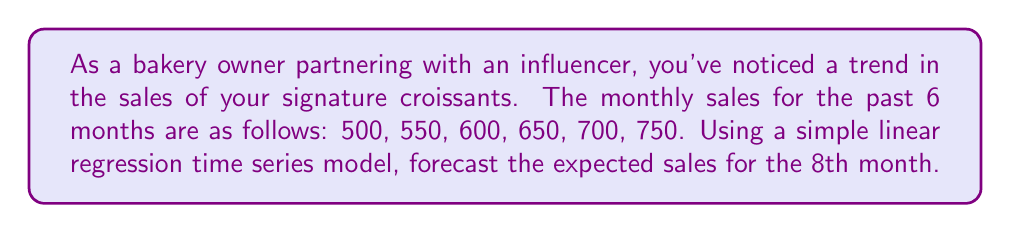Give your solution to this math problem. To forecast the sales for the 8th month using a simple linear regression time series model, we'll follow these steps:

1) First, let's set up our data:
   Time (t): 1, 2, 3, 4, 5, 6
   Sales (Y): 500, 550, 600, 650, 700, 750

2) We need to find the equation of the line: $Y = a + bt$, where:
   $a$ is the y-intercept
   $b$ is the slope
   $t$ is the time period

3) To find $b$, we use the formula:
   $$b = \frac{n\sum{ty} - \sum{t}\sum{y}}{n\sum{t^2} - (\sum{t})^2}$$

   Where $n$ is the number of data points (6 in this case)

4) Let's calculate the necessary sums:
   $\sum{t} = 1 + 2 + 3 + 4 + 5 + 6 = 21$
   $\sum{y} = 500 + 550 + 600 + 650 + 700 + 750 = 3750$
   $\sum{ty} = 1(500) + 2(550) + 3(600) + 4(650) + 5(700) + 6(750) = 13,900$
   $\sum{t^2} = 1^2 + 2^2 + 3^2 + 4^2 + 5^2 + 6^2 = 91$

5) Now we can calculate $b$:
   $$b = \frac{6(13,900) - 21(3750)}{6(91) - 21^2} = \frac{83,400 - 78,750}{546 - 441} = \frac{4650}{105} = 50$$

6) To find $a$, we use the formula:
   $$a = \bar{y} - b\bar{t}$$
   Where $\bar{y}$ is the mean of $y$ and $\bar{t}$ is the mean of $t$

   $\bar{y} = 3750 / 6 = 625$
   $\bar{t} = 21 / 6 = 3.5$

   $a = 625 - 50(3.5) = 450$

7) Our regression equation is: $Y = 450 + 50t$

8) To forecast the 8th month, we substitute $t = 8$:
   $Y = 450 + 50(8) = 450 + 400 = 850$

Therefore, the forecasted sales for the 8th month is 850 croissants.
Answer: 850 croissants 